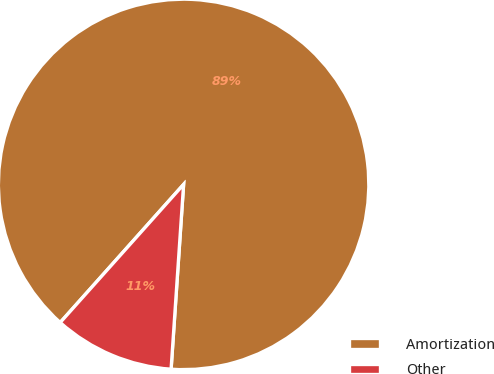Convert chart. <chart><loc_0><loc_0><loc_500><loc_500><pie_chart><fcel>Amortization<fcel>Other<nl><fcel>89.47%<fcel>10.53%<nl></chart> 